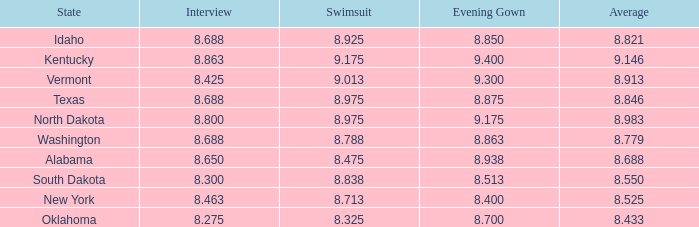What is the average interview score from Kentucky? 8.863. 